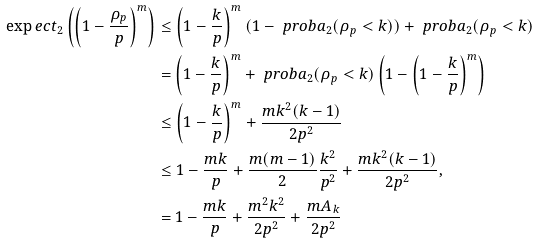<formula> <loc_0><loc_0><loc_500><loc_500>\exp e c t _ { 2 } \left ( \left ( 1 - \frac { \rho _ { p } } { p } \right ) ^ { m } \right ) & \leq \left ( 1 - \frac { k } { p } \right ) ^ { m } ( 1 - \ p r o b a _ { 2 } ( \rho _ { p } < k ) ) + \ p r o b a _ { 2 } ( \rho _ { p } < k ) \\ & = \left ( 1 - \frac { k } { p } \right ) ^ { m } + \ p r o b a _ { 2 } ( \rho _ { p } < k ) \left ( 1 - \left ( 1 - \frac { k } { p } \right ) ^ { m } \right ) \\ & \leq \left ( 1 - \frac { k } { p } \right ) ^ { m } + \frac { m k ^ { 2 } ( k - 1 ) } { 2 p ^ { 2 } } \\ & \leq 1 - \frac { m k } { p } + \frac { m ( m - 1 ) } { 2 } \frac { k ^ { 2 } } { p ^ { 2 } } + \frac { m k ^ { 2 } ( k - 1 ) } { 2 p ^ { 2 } } , \\ & = 1 - \frac { m k } { p } + \frac { m ^ { 2 } k ^ { 2 } } { 2 p ^ { 2 } } + \frac { m A _ { k } } { 2 p ^ { 2 } }</formula> 